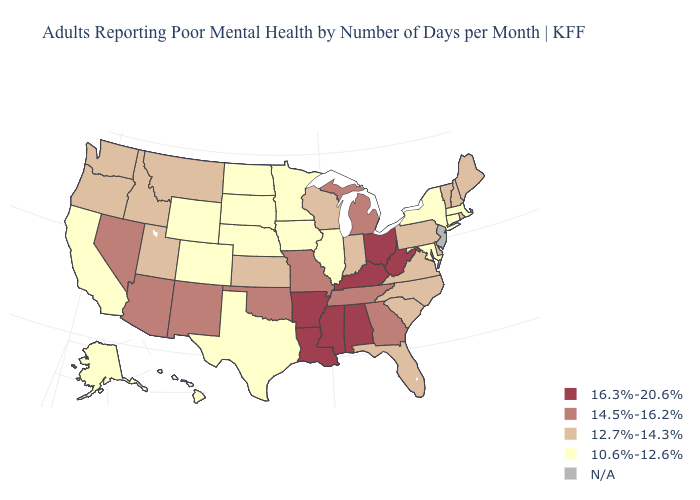What is the highest value in the MidWest ?
Concise answer only. 16.3%-20.6%. What is the value of Florida?
Concise answer only. 12.7%-14.3%. Among the states that border Michigan , does Ohio have the lowest value?
Be succinct. No. Does New York have the lowest value in the USA?
Short answer required. Yes. Does Kansas have the lowest value in the USA?
Quick response, please. No. Among the states that border New York , which have the highest value?
Keep it brief. Pennsylvania, Vermont. What is the highest value in states that border Louisiana?
Give a very brief answer. 16.3%-20.6%. What is the lowest value in states that border Oklahoma?
Concise answer only. 10.6%-12.6%. What is the highest value in the USA?
Keep it brief. 16.3%-20.6%. What is the highest value in the MidWest ?
Quick response, please. 16.3%-20.6%. Which states have the lowest value in the USA?
Answer briefly. Alaska, California, Colorado, Connecticut, Hawaii, Illinois, Iowa, Maryland, Massachusetts, Minnesota, Nebraska, New York, North Dakota, South Dakota, Texas, Wyoming. What is the highest value in the USA?
Give a very brief answer. 16.3%-20.6%. Among the states that border Oregon , which have the lowest value?
Write a very short answer. California. Name the states that have a value in the range 12.7%-14.3%?
Keep it brief. Delaware, Florida, Idaho, Indiana, Kansas, Maine, Montana, New Hampshire, North Carolina, Oregon, Pennsylvania, Rhode Island, South Carolina, Utah, Vermont, Virginia, Washington, Wisconsin. Name the states that have a value in the range 14.5%-16.2%?
Answer briefly. Arizona, Georgia, Michigan, Missouri, Nevada, New Mexico, Oklahoma, Tennessee. 